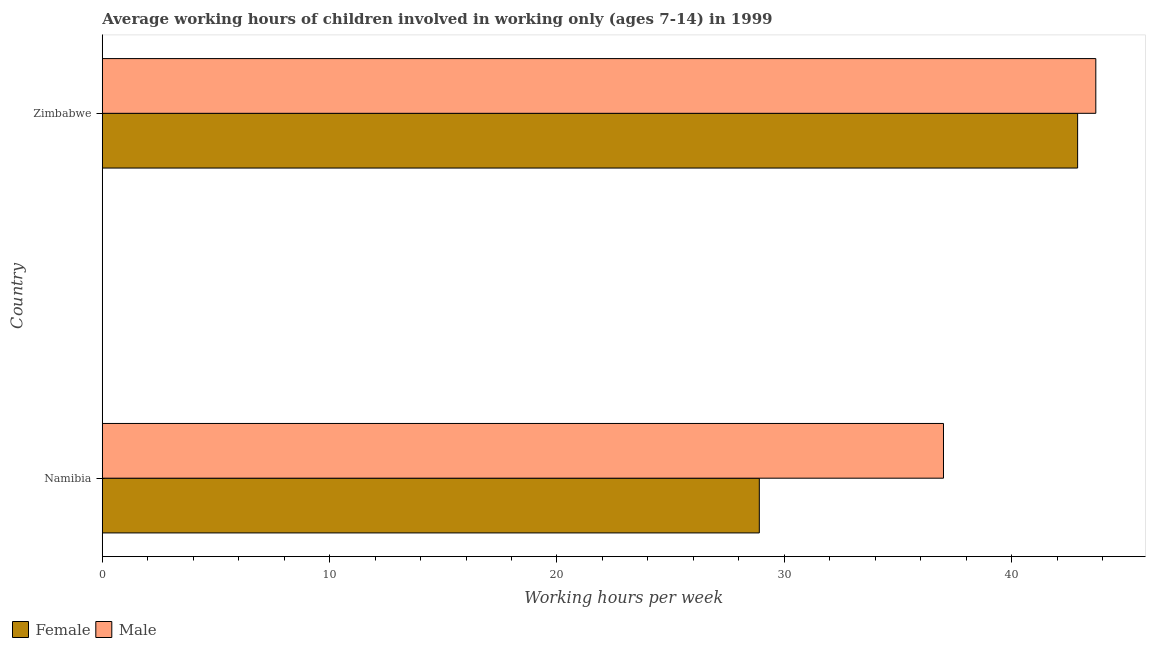How many different coloured bars are there?
Your answer should be very brief. 2. Are the number of bars per tick equal to the number of legend labels?
Your answer should be very brief. Yes. How many bars are there on the 1st tick from the top?
Offer a terse response. 2. How many bars are there on the 1st tick from the bottom?
Keep it short and to the point. 2. What is the label of the 2nd group of bars from the top?
Provide a succinct answer. Namibia. What is the average working hour of male children in Zimbabwe?
Provide a short and direct response. 43.7. Across all countries, what is the maximum average working hour of female children?
Give a very brief answer. 42.9. Across all countries, what is the minimum average working hour of female children?
Offer a terse response. 28.9. In which country was the average working hour of male children maximum?
Give a very brief answer. Zimbabwe. In which country was the average working hour of female children minimum?
Make the answer very short. Namibia. What is the total average working hour of male children in the graph?
Make the answer very short. 80.7. What is the difference between the average working hour of male children in Namibia and that in Zimbabwe?
Give a very brief answer. -6.7. What is the difference between the average working hour of female children in Zimbabwe and the average working hour of male children in Namibia?
Provide a short and direct response. 5.9. What is the average average working hour of male children per country?
Offer a very short reply. 40.35. In how many countries, is the average working hour of female children greater than 26 hours?
Give a very brief answer. 2. What is the ratio of the average working hour of female children in Namibia to that in Zimbabwe?
Your answer should be compact. 0.67. Is the average working hour of male children in Namibia less than that in Zimbabwe?
Your answer should be compact. Yes. Is the difference between the average working hour of male children in Namibia and Zimbabwe greater than the difference between the average working hour of female children in Namibia and Zimbabwe?
Make the answer very short. Yes. In how many countries, is the average working hour of male children greater than the average average working hour of male children taken over all countries?
Provide a short and direct response. 1. What does the 2nd bar from the top in Namibia represents?
Make the answer very short. Female. What does the 2nd bar from the bottom in Zimbabwe represents?
Provide a short and direct response. Male. How many countries are there in the graph?
Offer a very short reply. 2. What is the difference between two consecutive major ticks on the X-axis?
Ensure brevity in your answer.  10. How many legend labels are there?
Give a very brief answer. 2. How are the legend labels stacked?
Provide a short and direct response. Horizontal. What is the title of the graph?
Your answer should be compact. Average working hours of children involved in working only (ages 7-14) in 1999. What is the label or title of the X-axis?
Keep it short and to the point. Working hours per week. What is the label or title of the Y-axis?
Make the answer very short. Country. What is the Working hours per week of Female in Namibia?
Provide a short and direct response. 28.9. What is the Working hours per week in Female in Zimbabwe?
Your response must be concise. 42.9. What is the Working hours per week of Male in Zimbabwe?
Keep it short and to the point. 43.7. Across all countries, what is the maximum Working hours per week of Female?
Give a very brief answer. 42.9. Across all countries, what is the maximum Working hours per week of Male?
Provide a succinct answer. 43.7. Across all countries, what is the minimum Working hours per week in Female?
Offer a very short reply. 28.9. Across all countries, what is the minimum Working hours per week in Male?
Offer a terse response. 37. What is the total Working hours per week in Female in the graph?
Your answer should be compact. 71.8. What is the total Working hours per week of Male in the graph?
Keep it short and to the point. 80.7. What is the difference between the Working hours per week of Female in Namibia and the Working hours per week of Male in Zimbabwe?
Your answer should be very brief. -14.8. What is the average Working hours per week of Female per country?
Offer a very short reply. 35.9. What is the average Working hours per week of Male per country?
Your answer should be compact. 40.35. What is the difference between the Working hours per week of Female and Working hours per week of Male in Zimbabwe?
Offer a very short reply. -0.8. What is the ratio of the Working hours per week in Female in Namibia to that in Zimbabwe?
Ensure brevity in your answer.  0.67. What is the ratio of the Working hours per week in Male in Namibia to that in Zimbabwe?
Provide a short and direct response. 0.85. What is the difference between the highest and the lowest Working hours per week of Male?
Offer a very short reply. 6.7. 